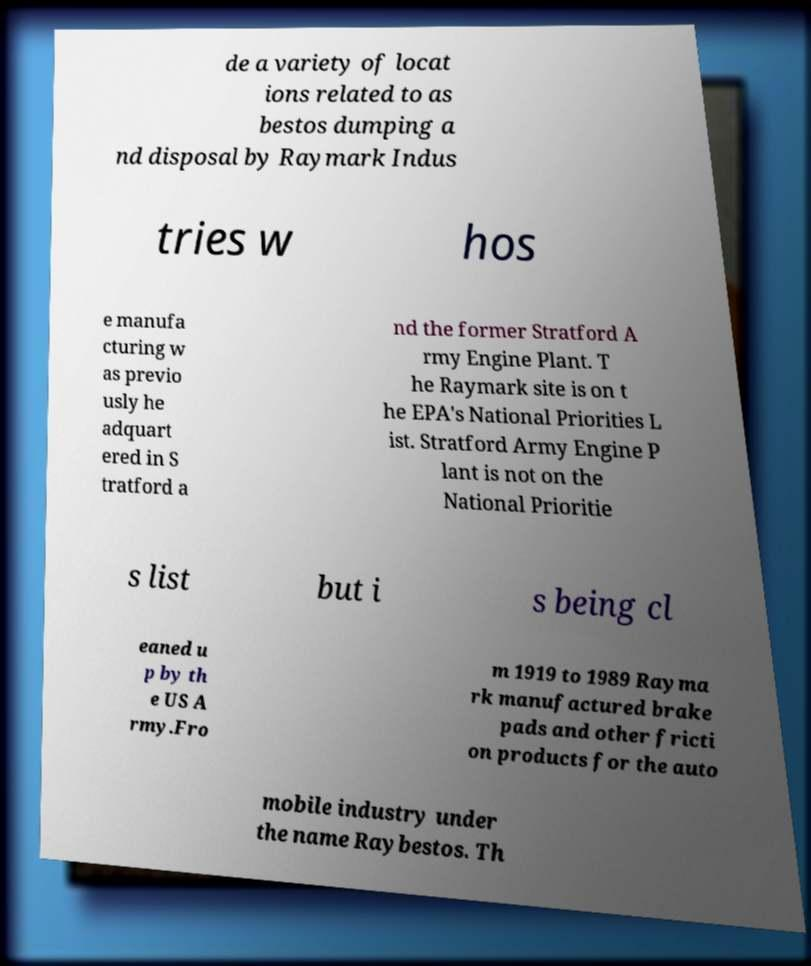Please read and relay the text visible in this image. What does it say? de a variety of locat ions related to as bestos dumping a nd disposal by Raymark Indus tries w hos e manufa cturing w as previo usly he adquart ered in S tratford a nd the former Stratford A rmy Engine Plant. T he Raymark site is on t he EPA's National Priorities L ist. Stratford Army Engine P lant is not on the National Prioritie s list but i s being cl eaned u p by th e US A rmy.Fro m 1919 to 1989 Rayma rk manufactured brake pads and other fricti on products for the auto mobile industry under the name Raybestos. Th 